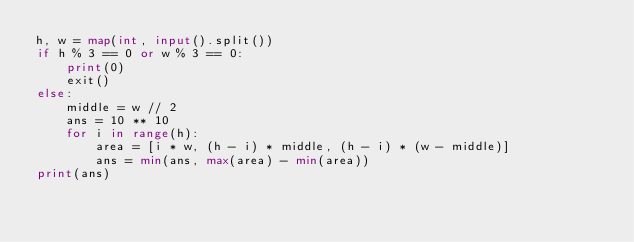<code> <loc_0><loc_0><loc_500><loc_500><_Python_>h, w = map(int, input().split())
if h % 3 == 0 or w % 3 == 0:
    print(0)
    exit()
else:
    middle = w // 2
    ans = 10 ** 10
    for i in range(h):
        area = [i * w, (h - i) * middle, (h - i) * (w - middle)]
        ans = min(ans, max(area) - min(area))
print(ans)</code> 